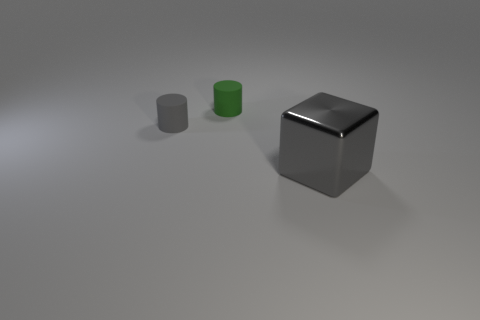Is there a rubber object of the same shape as the large metallic thing?
Offer a terse response. No. Are the small thing in front of the green rubber thing and the gray thing that is on the right side of the small gray thing made of the same material?
Your answer should be very brief. No. What is the size of the cylinder on the left side of the matte object behind the gray matte object that is in front of the green rubber cylinder?
Offer a very short reply. Small. What is the material of the thing that is the same size as the green cylinder?
Ensure brevity in your answer.  Rubber. Are there any gray shiny things of the same size as the gray cylinder?
Provide a succinct answer. No. Is the shape of the small gray object the same as the gray metal thing?
Your response must be concise. No. Is there a cylinder to the left of the gray object that is behind the gray object to the right of the green object?
Keep it short and to the point. No. There is a gray thing behind the large metal thing; is its size the same as the rubber thing right of the gray cylinder?
Your answer should be very brief. Yes. Are there an equal number of small gray cylinders in front of the gray rubber thing and large metal objects that are on the left side of the big gray shiny object?
Offer a very short reply. Yes. Are there any other things that are made of the same material as the large thing?
Your answer should be very brief. No. 